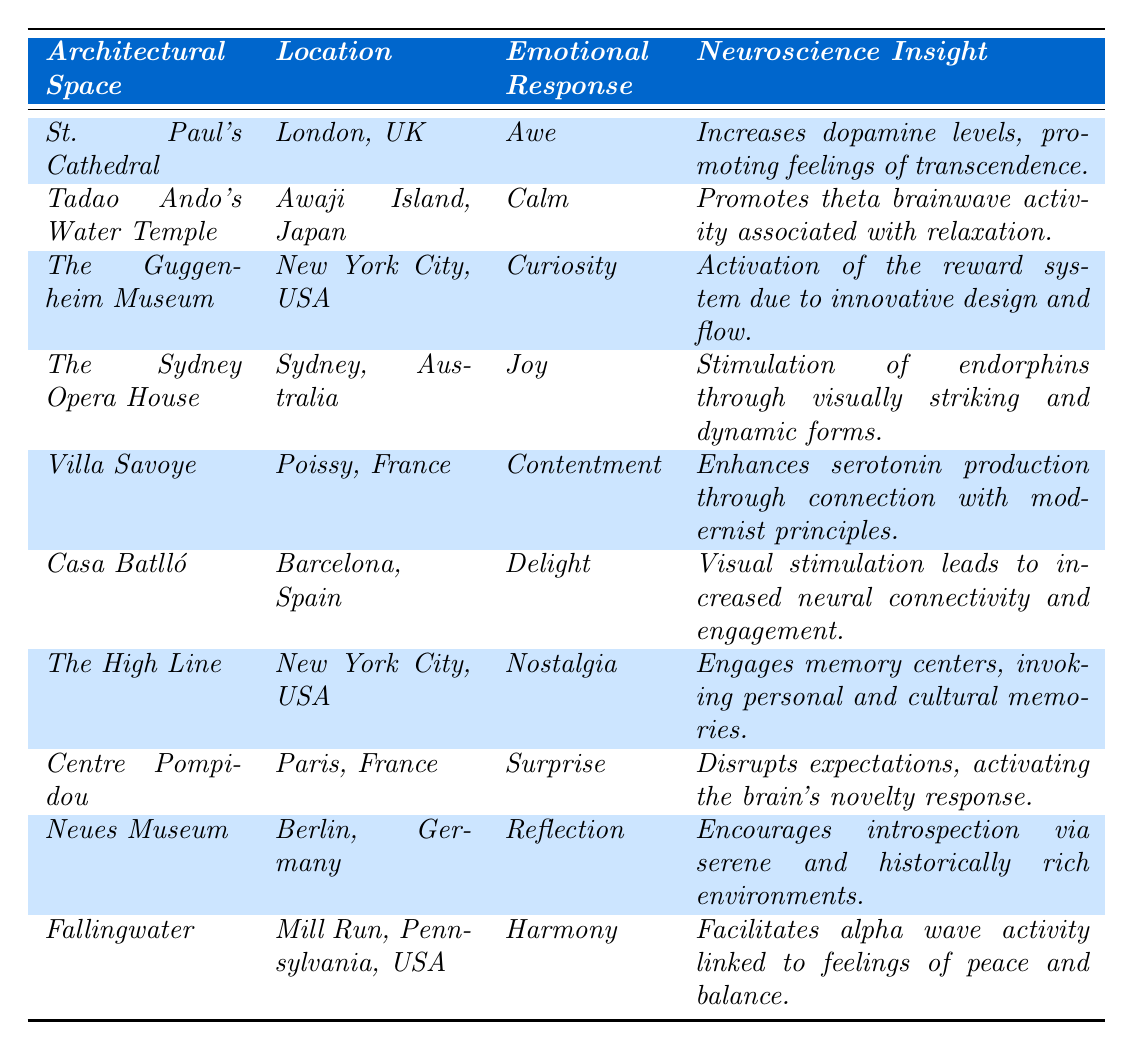What is the emotional response associated with Fallingwater? The emotional response for Fallingwater can be found directly in the table under the "Emotional Response" column for that architectural space. It is listed as "Harmony."
Answer: Harmony Which architectural space elicits feelings of nostalgia? According to the table, "The High Line" is the architectural space that is associated with nostalgia, as indicated in the "Emotional Response" column.
Answer: The High Line How many different emotional responses are represented in the table? To find the total number of unique emotional responses, we can count them in the "Emotional Response" column: Awe, Calm, Curiosity, Joy, Contentment, Delight, Nostalgia, Surprise, Reflection, Harmony. There are 10 unique responses.
Answer: 10 Is there an architectural space that promotes calmness? The table indicates that Tadao Ando's Water Temple promotes calmness, as stated in the emotional response column.
Answer: Yes Which emotional response is linked to the Centre Pompidou? The response linked to the Centre Pompidou is "Surprise," as noted in the emotional response column for that architectural space.
Answer: Surprise Which architectural space shows the highest stimulation of endorphins? The Sydney Opera House is associated with the highest stimulation of endorphins due to its visually striking and dynamic forms, according to the neuroscience insight given for that space.
Answer: The Sydney Opera House Can you list the location of the architectural space that evokes reflection? The table shows that the Neues Museum is the space that evokes reflection, and its location is Berlin, Germany, as listed in the corresponding row.
Answer: Berlin, Germany Which emotional response is most frequently represented in the table? By analyzing the table, we can see that each emotional response is unique, with no repetitions. Therefore, there is no "most frequently" represented emotional response; all are equally represented once.
Answer: None What is the neuroscience insight related to the emotional response of joy? The Sydney Opera House, which evokes joy, states that the neuroscience insight is the stimulation of endorphins through its visually striking and dynamic forms.
Answer: Stimulation of endorphins How does the emotional response of 'Delight' relate to neural connectivity? The table explains that Casa Batlló evokes delight, leading to increased neural connectivity and engagement, as specified in its associated neuroscience insight.
Answer: Increased neural connectivity and engagement 